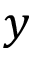Convert formula to latex. <formula><loc_0><loc_0><loc_500><loc_500>y</formula> 